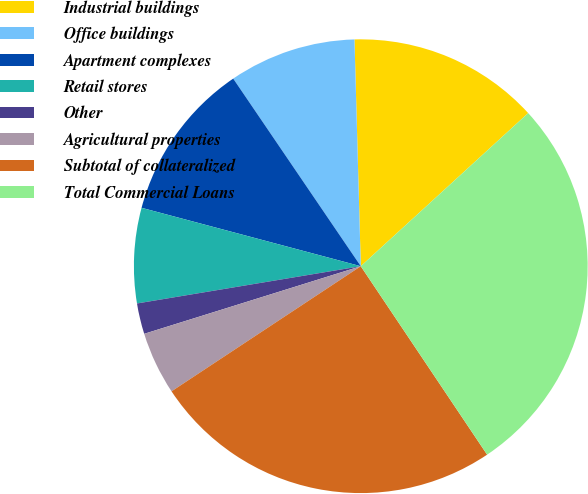Convert chart to OTSL. <chart><loc_0><loc_0><loc_500><loc_500><pie_chart><fcel>Industrial buildings<fcel>Office buildings<fcel>Apartment complexes<fcel>Retail stores<fcel>Other<fcel>Agricultural properties<fcel>Subtotal of collateralized<fcel>Total Commercial Loans<nl><fcel>13.65%<fcel>9.06%<fcel>11.35%<fcel>6.77%<fcel>2.19%<fcel>4.48%<fcel>25.1%<fcel>27.39%<nl></chart> 